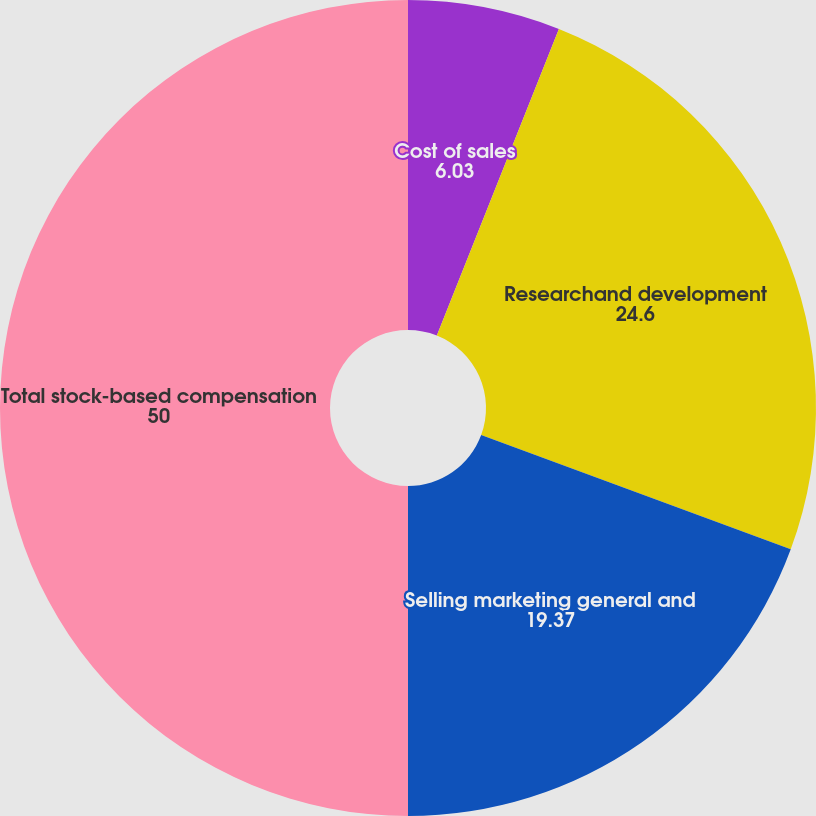Convert chart. <chart><loc_0><loc_0><loc_500><loc_500><pie_chart><fcel>Cost of sales<fcel>Researchand development<fcel>Selling marketing general and<fcel>Total stock-based compensation<nl><fcel>6.03%<fcel>24.6%<fcel>19.37%<fcel>50.0%<nl></chart> 